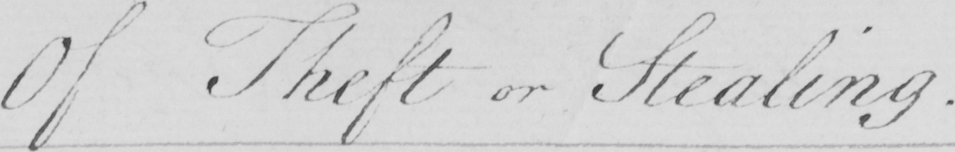Can you read and transcribe this handwriting? Of Theft or Stealing . 